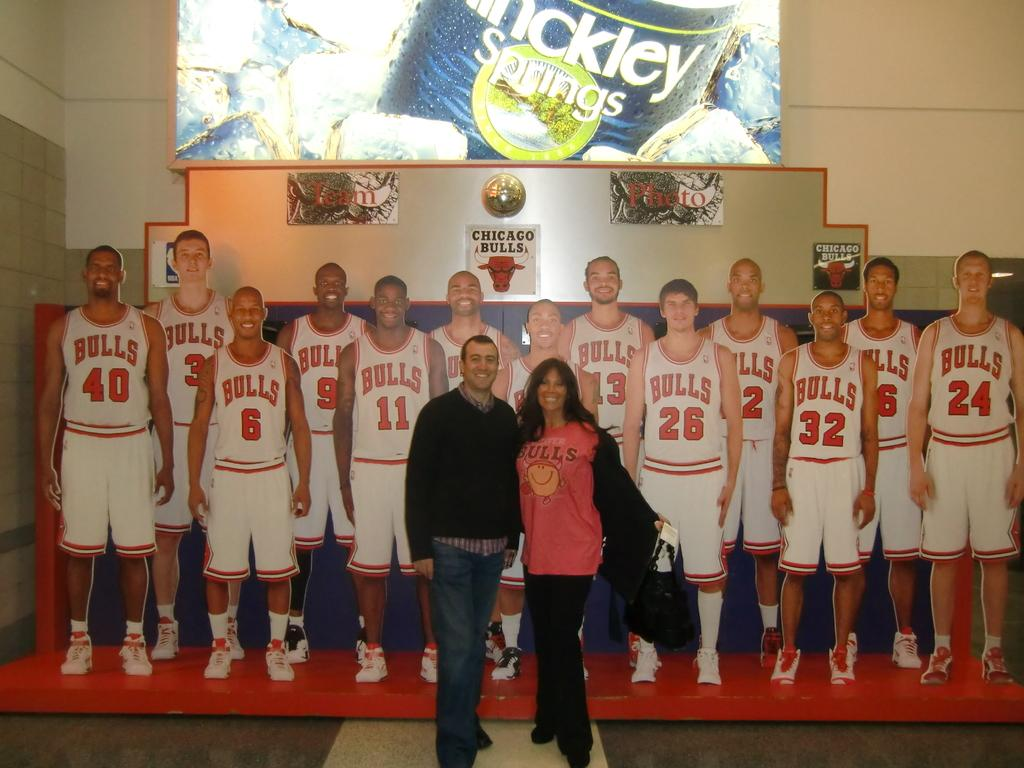<image>
Present a compact description of the photo's key features. Two people pose in front of a Bulls team photo. 